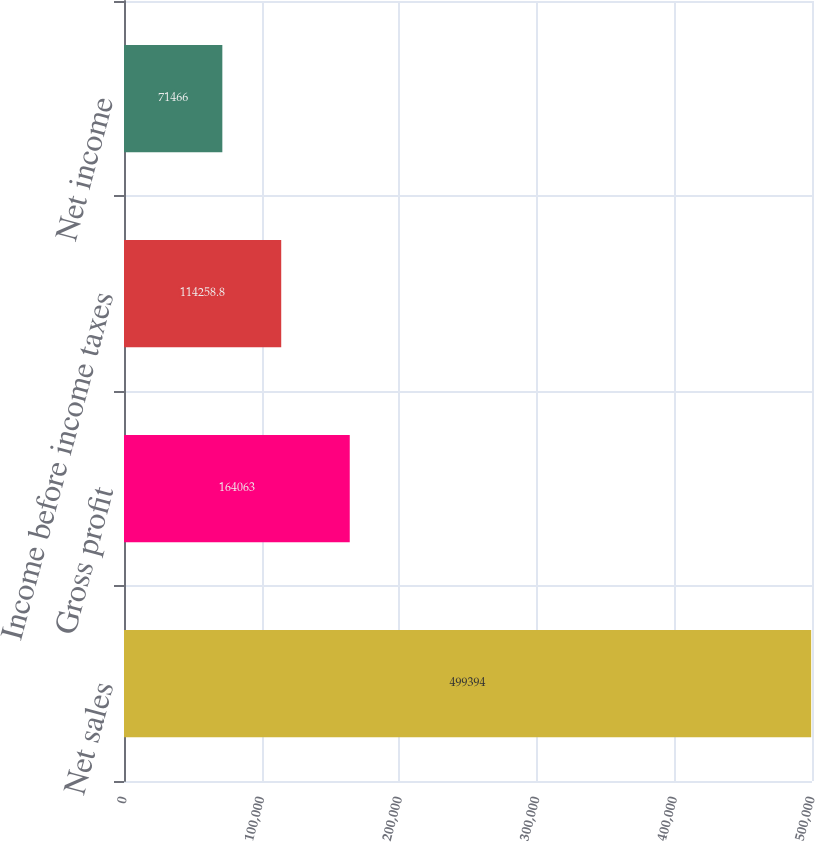Convert chart to OTSL. <chart><loc_0><loc_0><loc_500><loc_500><bar_chart><fcel>Net sales<fcel>Gross profit<fcel>Income before income taxes<fcel>Net income<nl><fcel>499394<fcel>164063<fcel>114259<fcel>71466<nl></chart> 